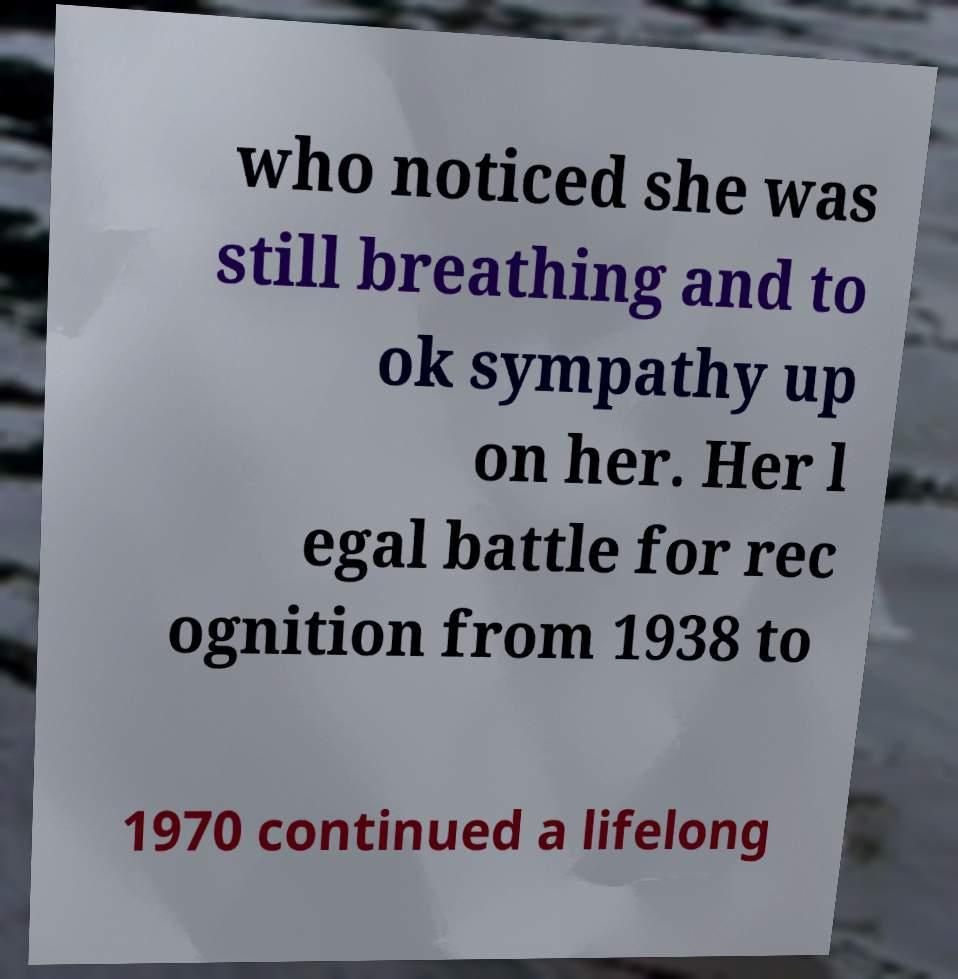Can you read and provide the text displayed in the image?This photo seems to have some interesting text. Can you extract and type it out for me? who noticed she was still breathing and to ok sympathy up on her. Her l egal battle for rec ognition from 1938 to 1970 continued a lifelong 